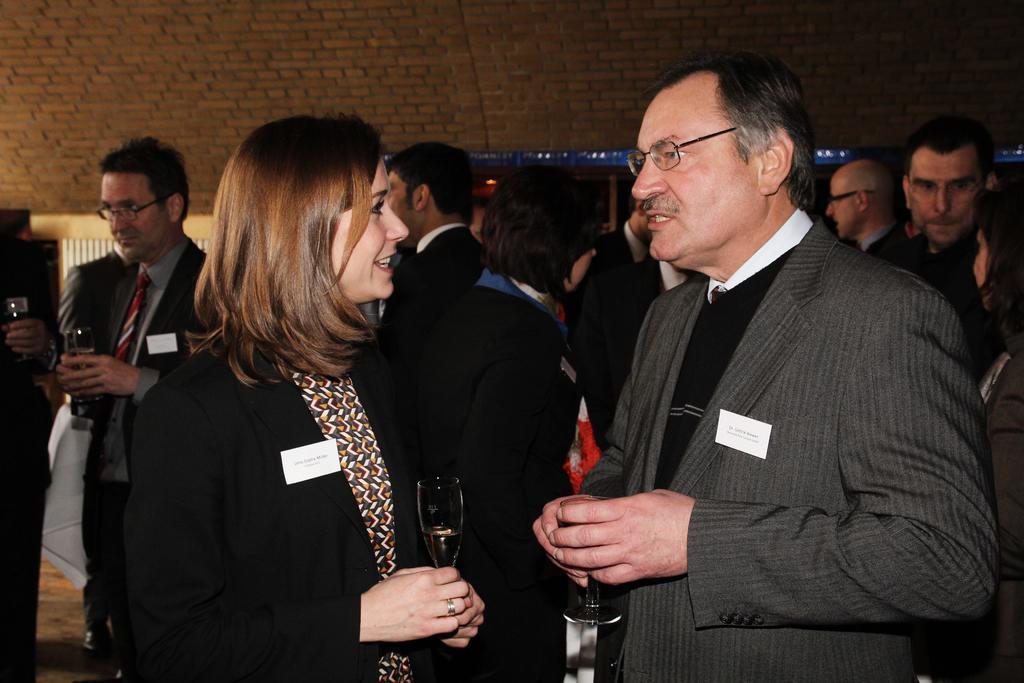Describe this image in one or two sentences. There are people standing and these two people holding glasses. In the background we can see wall. 